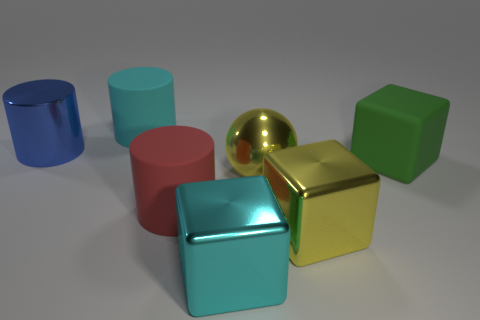There is a big cyan cylinder; are there any red rubber things behind it?
Offer a very short reply. No. How many other things are there of the same shape as the red rubber thing?
Make the answer very short. 2. There is a shiny cylinder that is the same size as the shiny ball; what color is it?
Your response must be concise. Blue. Are there fewer cyan objects right of the large green cube than green matte things in front of the large shiny ball?
Your response must be concise. No. There is a large metal object on the left side of the big red matte thing that is in front of the big metallic sphere; what number of big cyan objects are on the left side of it?
Provide a short and direct response. 0. Is the number of big objects that are to the left of the big blue cylinder less than the number of red cylinders?
Your answer should be compact. Yes. Is the red object the same shape as the blue metallic object?
Make the answer very short. Yes. The other metal thing that is the same shape as the cyan metallic object is what color?
Your response must be concise. Yellow. How many metal cubes have the same color as the sphere?
Your response must be concise. 1. How many things are either matte cylinders behind the rubber block or large purple rubber cubes?
Keep it short and to the point. 1. 